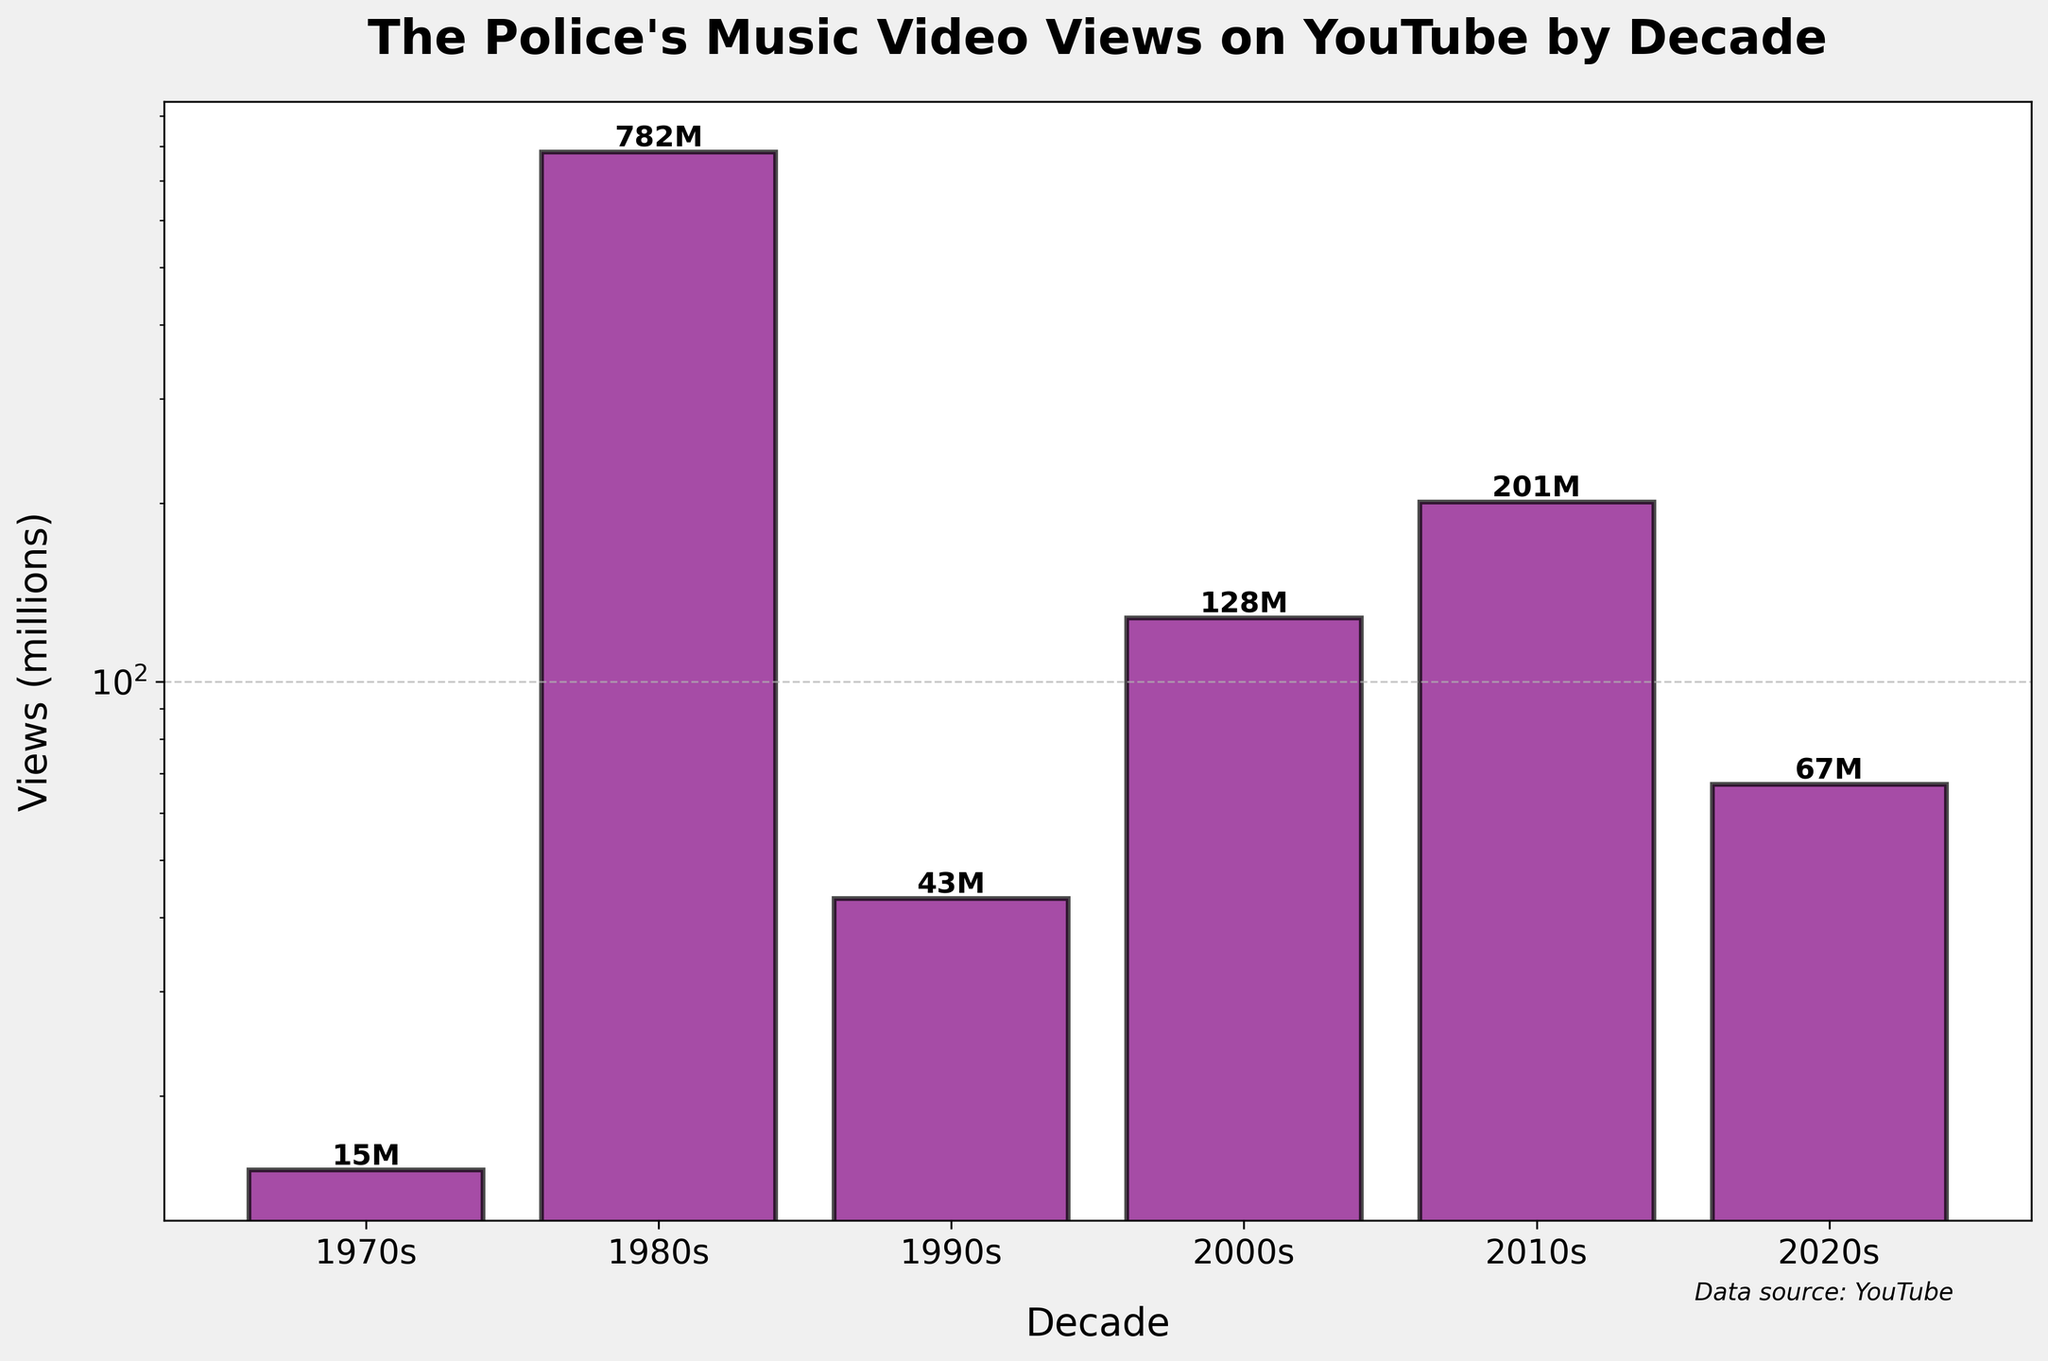What is the title of the chart? The title is displayed prominently at the top of the chart. It reads "The Police's Music Video Views on YouTube by Decade".
Answer: "The Police's Music Video Views on YouTube by Decade" Which decade has the highest number of views? By observing the heights of the bars, it is clear that the bar representing the 1980s is the tallest. Consequently, the 1980s have the highest number of views.
Answer: 1980s How many millions of views are recorded for the 2010s? The height of the bar for the 2010s indicates the number of views, which is shown with a text label on top of the bar. The label reads "201M".
Answer: 201 Million Which decade had more views, the 1970s or the 2000s, and by how much? The bar for the 2000s is higher than for the 1970s. The 2000s have 128M views, and the 1970s have 15M views. The difference is 128 - 15 = 113M.
Answer: 2000s by 113 Million What is the sum of the views from the 1990s and the 2020s? The bars for the 1990s and 2020s show 43M and 67M views, respectively. Adding them together gives 43 + 67 = 110M views.
Answer: 110 Million Is the number of views for the 2020s greater than or less than the 2010s? By comparing the heights of the respective bars, it is clear that the views for the 2020s (67M) are less than those for the 2010s (201M).
Answer: Less than What is the average number of views per decade across all the data? Summing the views for all decades gives 15M + 782M + 43M + 128M + 201M + 67M = 1236M. Dividing by the number of decades (6) gives the average: 1236 / 6 = 206M.
Answer: 206 Million Which decade had the least views, and how many? By observing the smallest bar, the 1970s had the least views. The label on this bar indicates 15M views.
Answer: 1970s with 15 Million How much lower are the views for the 1990s compared to the 1980s? The bar for the 1980s shows 782M views and the one for the 1990s shows 43M views. The difference is 782 - 43 = 739M views.
Answer: 739 Million 